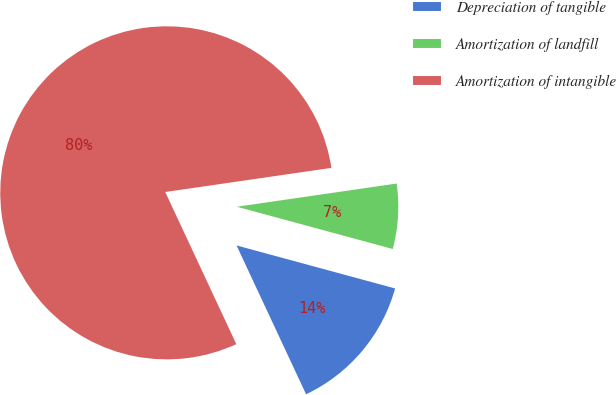Convert chart to OTSL. <chart><loc_0><loc_0><loc_500><loc_500><pie_chart><fcel>Depreciation of tangible<fcel>Amortization of landfill<fcel>Amortization of intangible<nl><fcel>13.83%<fcel>6.51%<fcel>79.66%<nl></chart> 